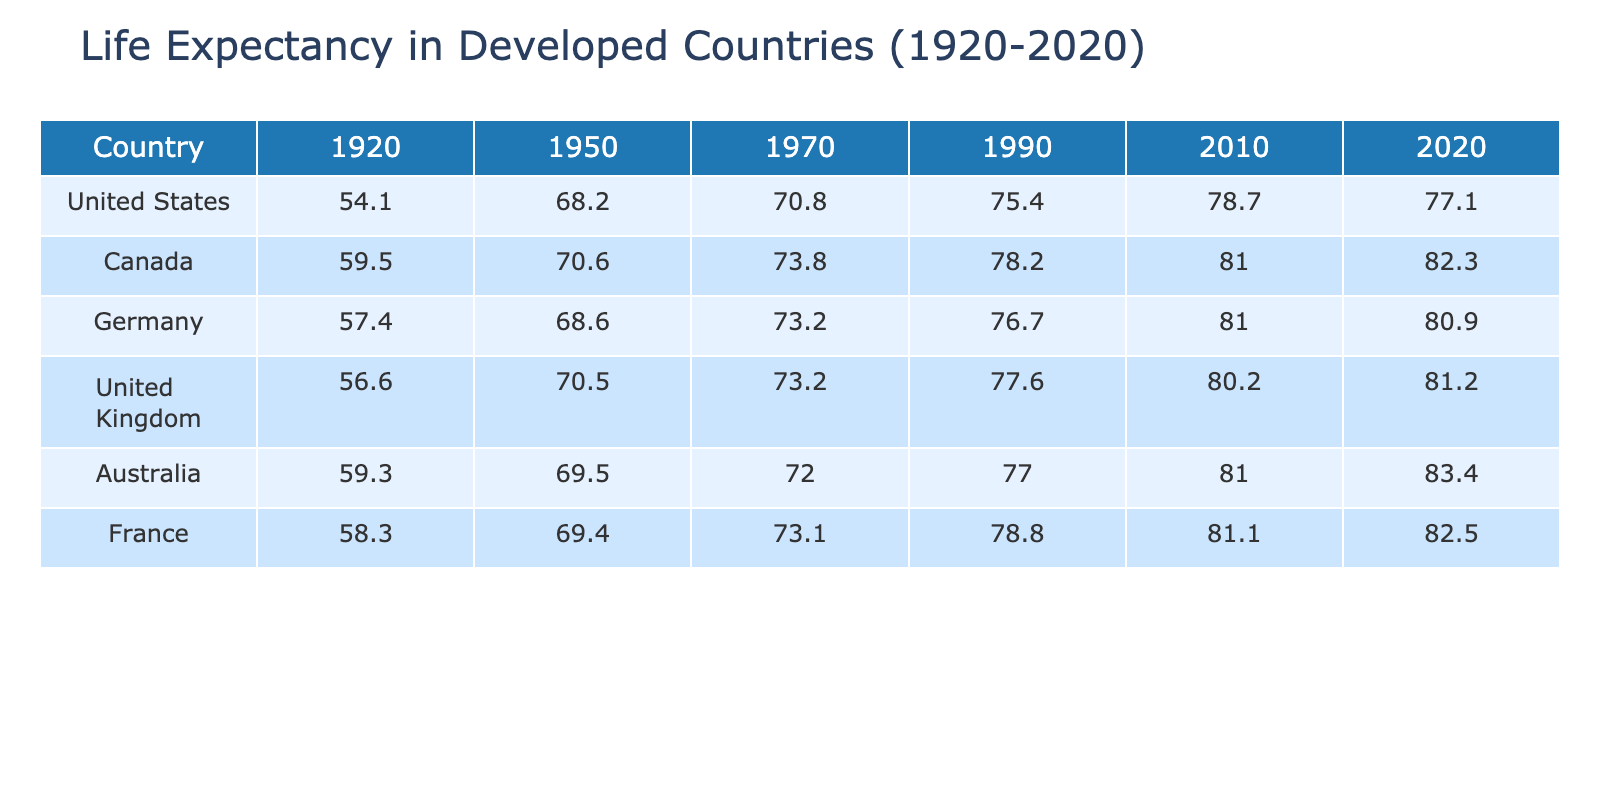What was the life expectancy in Canada in 1990? The table shows the life expectancy values for all countries by year. Looking at the row for Canada, the year 1990 shows a life expectancy of 78.2 years.
Answer: 78.2 Which country had the highest life expectancy in 2010? The table allows us to compare the life expectancy values in 2010 across all listed countries. Scanning through that year, Australia has the highest value at 81.0 years.
Answer: Australia What is the difference in life expectancy between the United States in 1950 and Germany in the same year? For the United States in 1950, the life expectancy is 68.2 years. For Germany, it is 68.6 years. The difference is calculated as 68.6 - 68.2 = 0.4 years.
Answer: 0.4 Was the life expectancy in the United Kingdom higher in 1970 than in Canada? Looking up United Kingdom's life expectancy in 1970, it is 73.2 years, and Canada’s at the same year is 73.8 years. Since 73.2 is less than 73.8, the statement is false.
Answer: No What was the average life expectancy across all countries in 2020? To find the average life expectancy in 2020, we sum the values: 77.1 (USA) + 82.3 (Canada) + 80.9 (Germany) + 81.2 (UK) + 83.4 (Australia) + 82.5 (France) = 487.4. There are 6 countries; thus, the average is 487.4 / 6 = 81.23 years.
Answer: 81.23 Which country experienced the largest increase in life expectancy from 1920 to 2020? We analyze the life expectancy values in 1920 and 2020 for each country: United States (54.1 to 77.1 = 23 years), Canada (59.5 to 82.3 = 22.8 years), Germany (57.4 to 80.9 = 23.5 years), United Kingdom (56.6 to 81.2 = 24.6 years), Australia (59.3 to 83.4 = 24.1 years), and France (58.3 to 82.5 = 24.2 years). The largest increase is for the United Kingdom, with 24.6 years of increase.
Answer: United Kingdom Is it true that life expectancy in Australia was below 80 years in 2010? Checking the table, Australia has a life expectancy of 81.0 years in 2010, which is indeed above 80. Therefore, the statement is false.
Answer: No What was the trend in life expectancy in Germany from 1970 to 2020? In 1970, Germany's life expectancy was 73.2 years, increasing to 80.9 years in 2020. This indicates a positive trend, showing improvement over the 50-year period.
Answer: Increase 